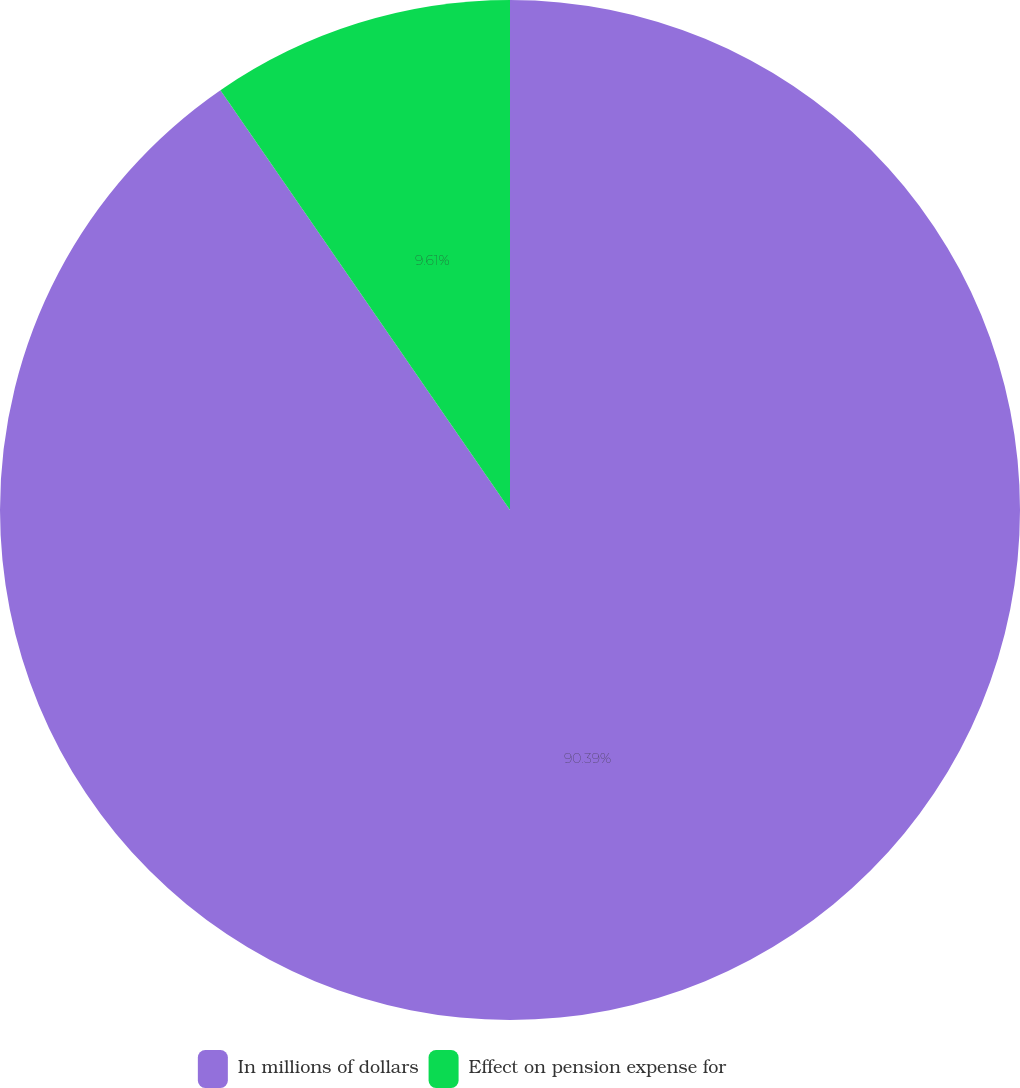<chart> <loc_0><loc_0><loc_500><loc_500><pie_chart><fcel>In millions of dollars<fcel>Effect on pension expense for<nl><fcel>90.39%<fcel>9.61%<nl></chart> 